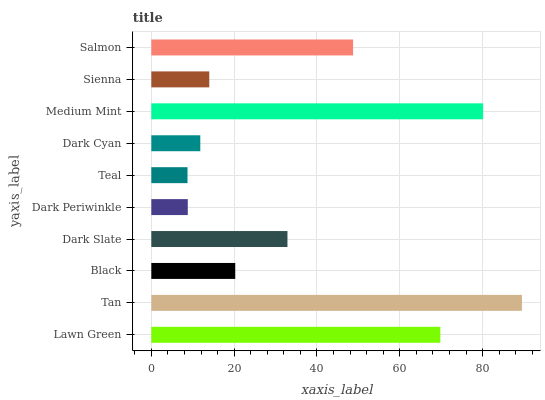Is Teal the minimum?
Answer yes or no. Yes. Is Tan the maximum?
Answer yes or no. Yes. Is Black the minimum?
Answer yes or no. No. Is Black the maximum?
Answer yes or no. No. Is Tan greater than Black?
Answer yes or no. Yes. Is Black less than Tan?
Answer yes or no. Yes. Is Black greater than Tan?
Answer yes or no. No. Is Tan less than Black?
Answer yes or no. No. Is Dark Slate the high median?
Answer yes or no. Yes. Is Black the low median?
Answer yes or no. Yes. Is Salmon the high median?
Answer yes or no. No. Is Sienna the low median?
Answer yes or no. No. 